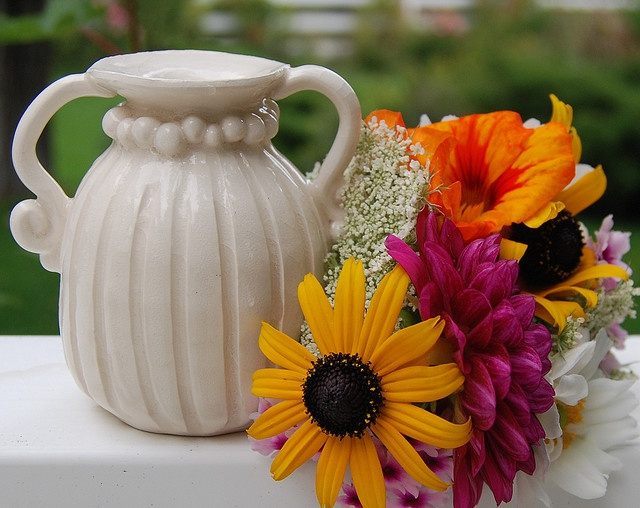Describe the objects in this image and their specific colors. I can see a vase in black, darkgray, lightgray, and gray tones in this image. 